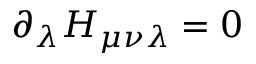Convert formula to latex. <formula><loc_0><loc_0><loc_500><loc_500>\partial _ { \lambda } H _ { \mu \nu \lambda } = 0</formula> 